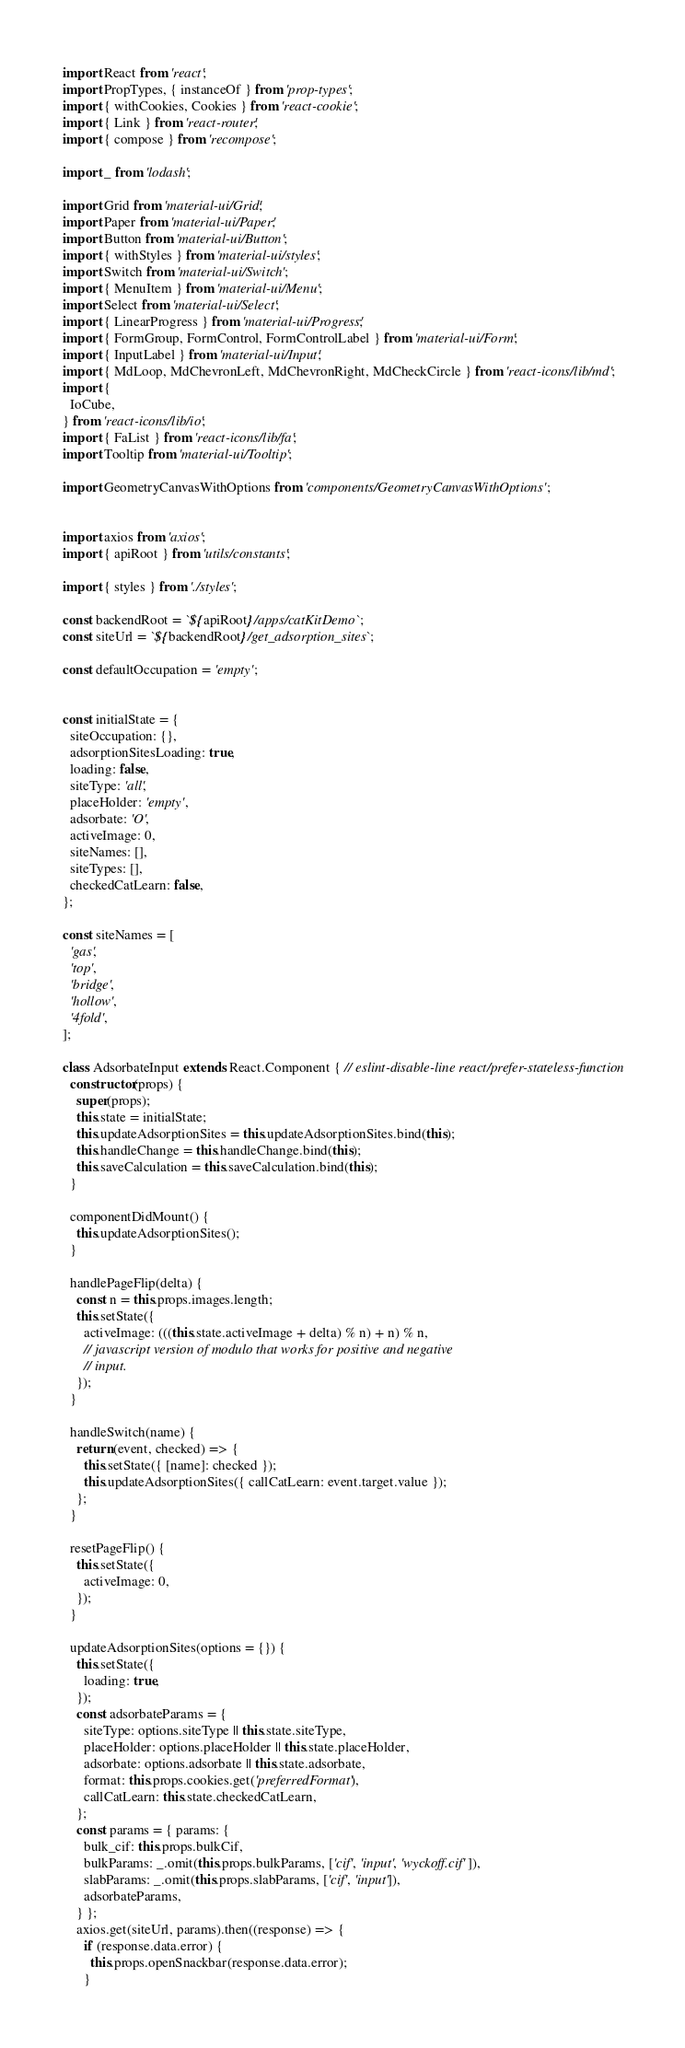<code> <loc_0><loc_0><loc_500><loc_500><_JavaScript_>import React from 'react';
import PropTypes, { instanceOf } from 'prop-types';
import { withCookies, Cookies } from 'react-cookie';
import { Link } from 'react-router';
import { compose } from 'recompose';

import _ from 'lodash';

import Grid from 'material-ui/Grid';
import Paper from 'material-ui/Paper';
import Button from 'material-ui/Button';
import { withStyles } from 'material-ui/styles';
import Switch from 'material-ui/Switch';
import { MenuItem } from 'material-ui/Menu';
import Select from 'material-ui/Select';
import { LinearProgress } from 'material-ui/Progress';
import { FormGroup, FormControl, FormControlLabel } from 'material-ui/Form';
import { InputLabel } from 'material-ui/Input';
import { MdLoop, MdChevronLeft, MdChevronRight, MdCheckCircle } from 'react-icons/lib/md';
import {
  IoCube,
} from 'react-icons/lib/io';
import { FaList } from 'react-icons/lib/fa';
import Tooltip from 'material-ui/Tooltip';

import GeometryCanvasWithOptions from 'components/GeometryCanvasWithOptions';


import axios from 'axios';
import { apiRoot } from 'utils/constants';

import { styles } from './styles';

const backendRoot = `${apiRoot}/apps/catKitDemo`;
const siteUrl = `${backendRoot}/get_adsorption_sites`;

const defaultOccupation = 'empty';


const initialState = {
  siteOccupation: {},
  adsorptionSitesLoading: true,
  loading: false,
  siteType: 'all',
  placeHolder: 'empty',
  adsorbate: 'O',
  activeImage: 0,
  siteNames: [],
  siteTypes: [],
  checkedCatLearn: false,
};

const siteNames = [
  'gas',
  'top',
  'bridge',
  'hollow',
  '4fold',
];

class AdsorbateInput extends React.Component { // eslint-disable-line react/prefer-stateless-function
  constructor(props) {
    super(props);
    this.state = initialState;
    this.updateAdsorptionSites = this.updateAdsorptionSites.bind(this);
    this.handleChange = this.handleChange.bind(this);
    this.saveCalculation = this.saveCalculation.bind(this);
  }

  componentDidMount() {
    this.updateAdsorptionSites();
  }

  handlePageFlip(delta) {
    const n = this.props.images.length;
    this.setState({
      activeImage: (((this.state.activeImage + delta) % n) + n) % n,
      // javascript version of modulo that works for positive and negative
      // input.
    });
  }

  handleSwitch(name) {
    return (event, checked) => {
      this.setState({ [name]: checked });
      this.updateAdsorptionSites({ callCatLearn: event.target.value });
    };
  }

  resetPageFlip() {
    this.setState({
      activeImage: 0,
    });
  }

  updateAdsorptionSites(options = {}) {
    this.setState({
      loading: true,
    });
    const adsorbateParams = {
      siteType: options.siteType || this.state.siteType,
      placeHolder: options.placeHolder || this.state.placeHolder,
      adsorbate: options.adsorbate || this.state.adsorbate,
      format: this.props.cookies.get('preferredFormat'),
      callCatLearn: this.state.checkedCatLearn,
    };
    const params = { params: {
      bulk_cif: this.props.bulkCif,
      bulkParams: _.omit(this.props.bulkParams, ['cif', 'input', 'wyckoff.cif']),
      slabParams: _.omit(this.props.slabParams, ['cif', 'input']),
      adsorbateParams,
    } };
    axios.get(siteUrl, params).then((response) => {
      if (response.data.error) {
        this.props.openSnackbar(response.data.error);
      }</code> 